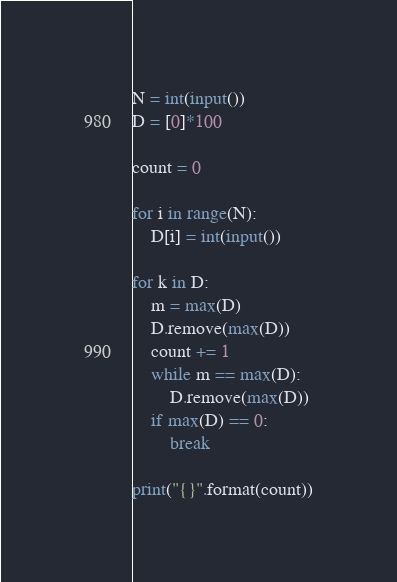<code> <loc_0><loc_0><loc_500><loc_500><_Python_>N = int(input())
D = [0]*100

count = 0

for i in range(N):
    D[i] = int(input())

for k in D:
    m = max(D)
    D.remove(max(D))
    count += 1
    while m == max(D):
        D.remove(max(D))
    if max(D) == 0:
        break

print("{}".format(count))</code> 